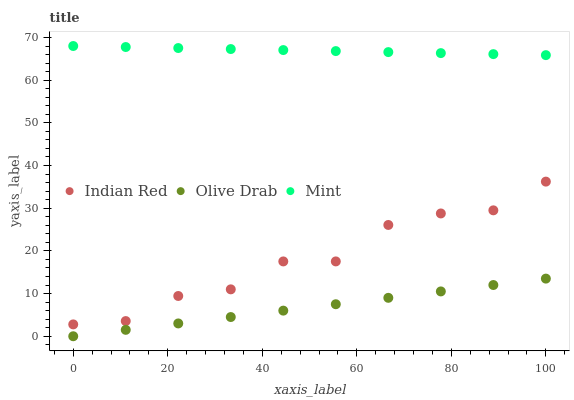Does Olive Drab have the minimum area under the curve?
Answer yes or no. Yes. Does Mint have the maximum area under the curve?
Answer yes or no. Yes. Does Indian Red have the minimum area under the curve?
Answer yes or no. No. Does Indian Red have the maximum area under the curve?
Answer yes or no. No. Is Olive Drab the smoothest?
Answer yes or no. Yes. Is Indian Red the roughest?
Answer yes or no. Yes. Is Indian Red the smoothest?
Answer yes or no. No. Is Olive Drab the roughest?
Answer yes or no. No. Does Olive Drab have the lowest value?
Answer yes or no. Yes. Does Indian Red have the lowest value?
Answer yes or no. No. Does Mint have the highest value?
Answer yes or no. Yes. Does Indian Red have the highest value?
Answer yes or no. No. Is Olive Drab less than Indian Red?
Answer yes or no. Yes. Is Mint greater than Olive Drab?
Answer yes or no. Yes. Does Olive Drab intersect Indian Red?
Answer yes or no. No. 